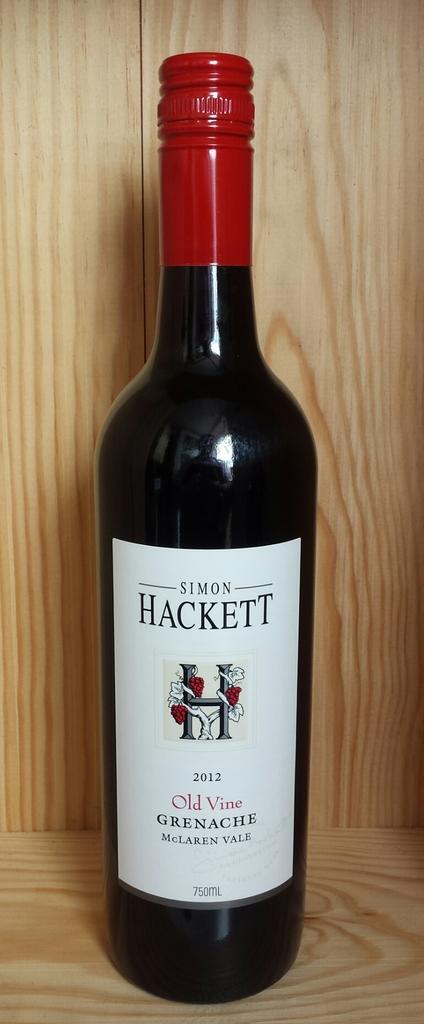Name this bottle?
Your answer should be very brief. Simon hackett. 